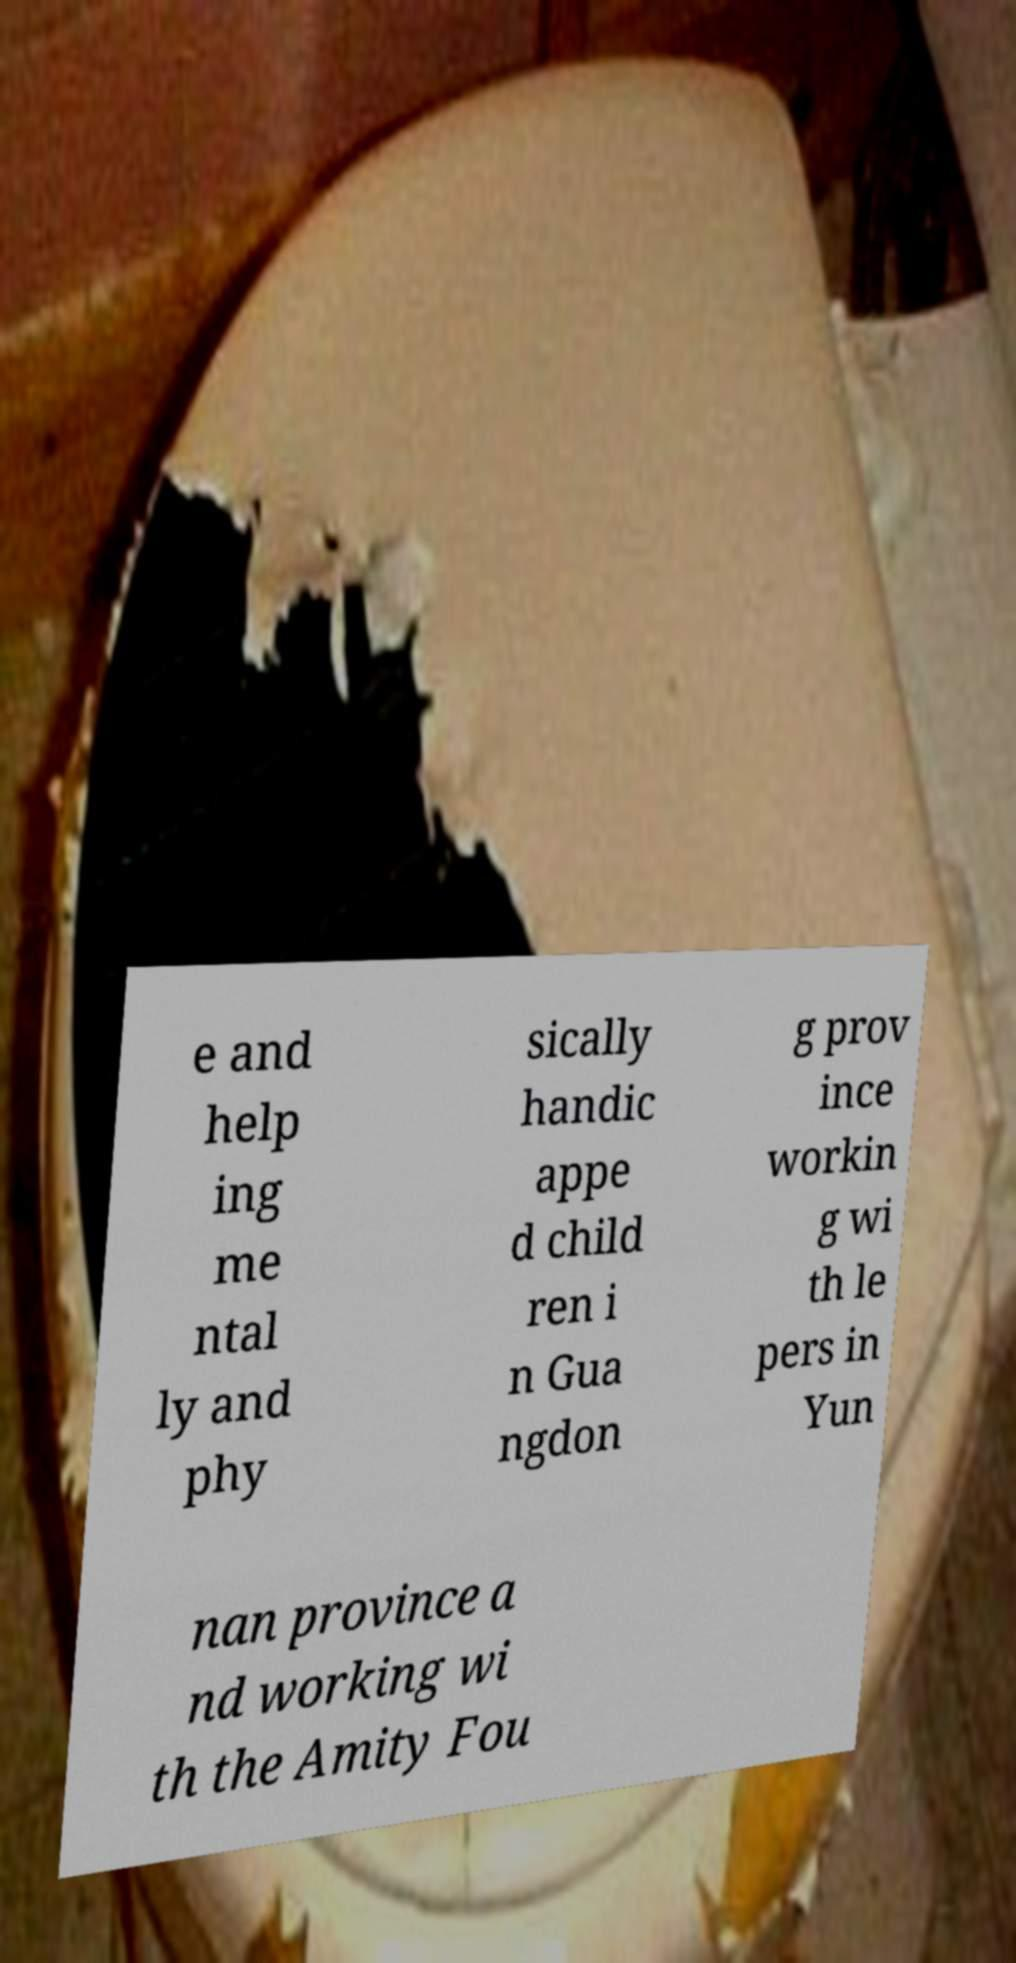Can you accurately transcribe the text from the provided image for me? e and help ing me ntal ly and phy sically handic appe d child ren i n Gua ngdon g prov ince workin g wi th le pers in Yun nan province a nd working wi th the Amity Fou 